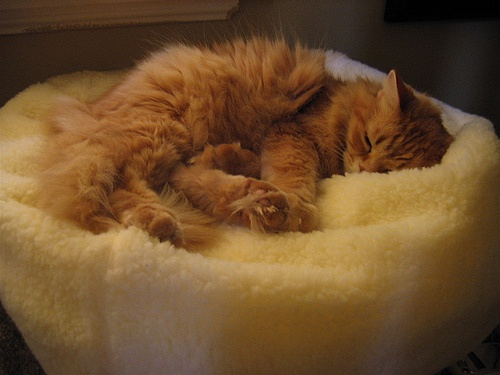Describe the objects in this image and their specific colors. I can see bed in black, maroon, tan, and olive tones and cat in black, brown, and maroon tones in this image. 